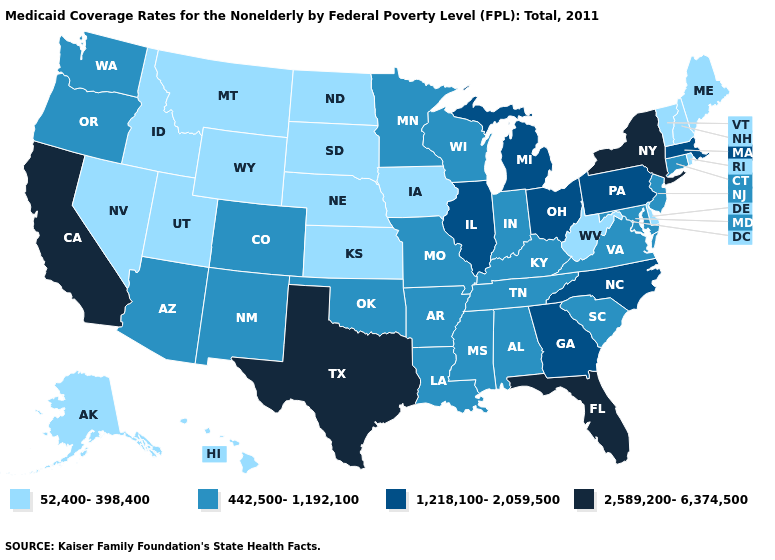What is the value of Wyoming?
Short answer required. 52,400-398,400. Does the map have missing data?
Be succinct. No. Does Delaware have the lowest value in the USA?
Answer briefly. Yes. Does the first symbol in the legend represent the smallest category?
Short answer required. Yes. What is the highest value in states that border Indiana?
Short answer required. 1,218,100-2,059,500. What is the value of Nevada?
Keep it brief. 52,400-398,400. What is the highest value in the West ?
Concise answer only. 2,589,200-6,374,500. What is the lowest value in the West?
Be succinct. 52,400-398,400. How many symbols are there in the legend?
Answer briefly. 4. Does Oklahoma have a lower value than Ohio?
Keep it brief. Yes. What is the highest value in the Northeast ?
Give a very brief answer. 2,589,200-6,374,500. Name the states that have a value in the range 1,218,100-2,059,500?
Give a very brief answer. Georgia, Illinois, Massachusetts, Michigan, North Carolina, Ohio, Pennsylvania. What is the value of Arkansas?
Give a very brief answer. 442,500-1,192,100. Does the map have missing data?
Answer briefly. No. What is the value of Tennessee?
Quick response, please. 442,500-1,192,100. 